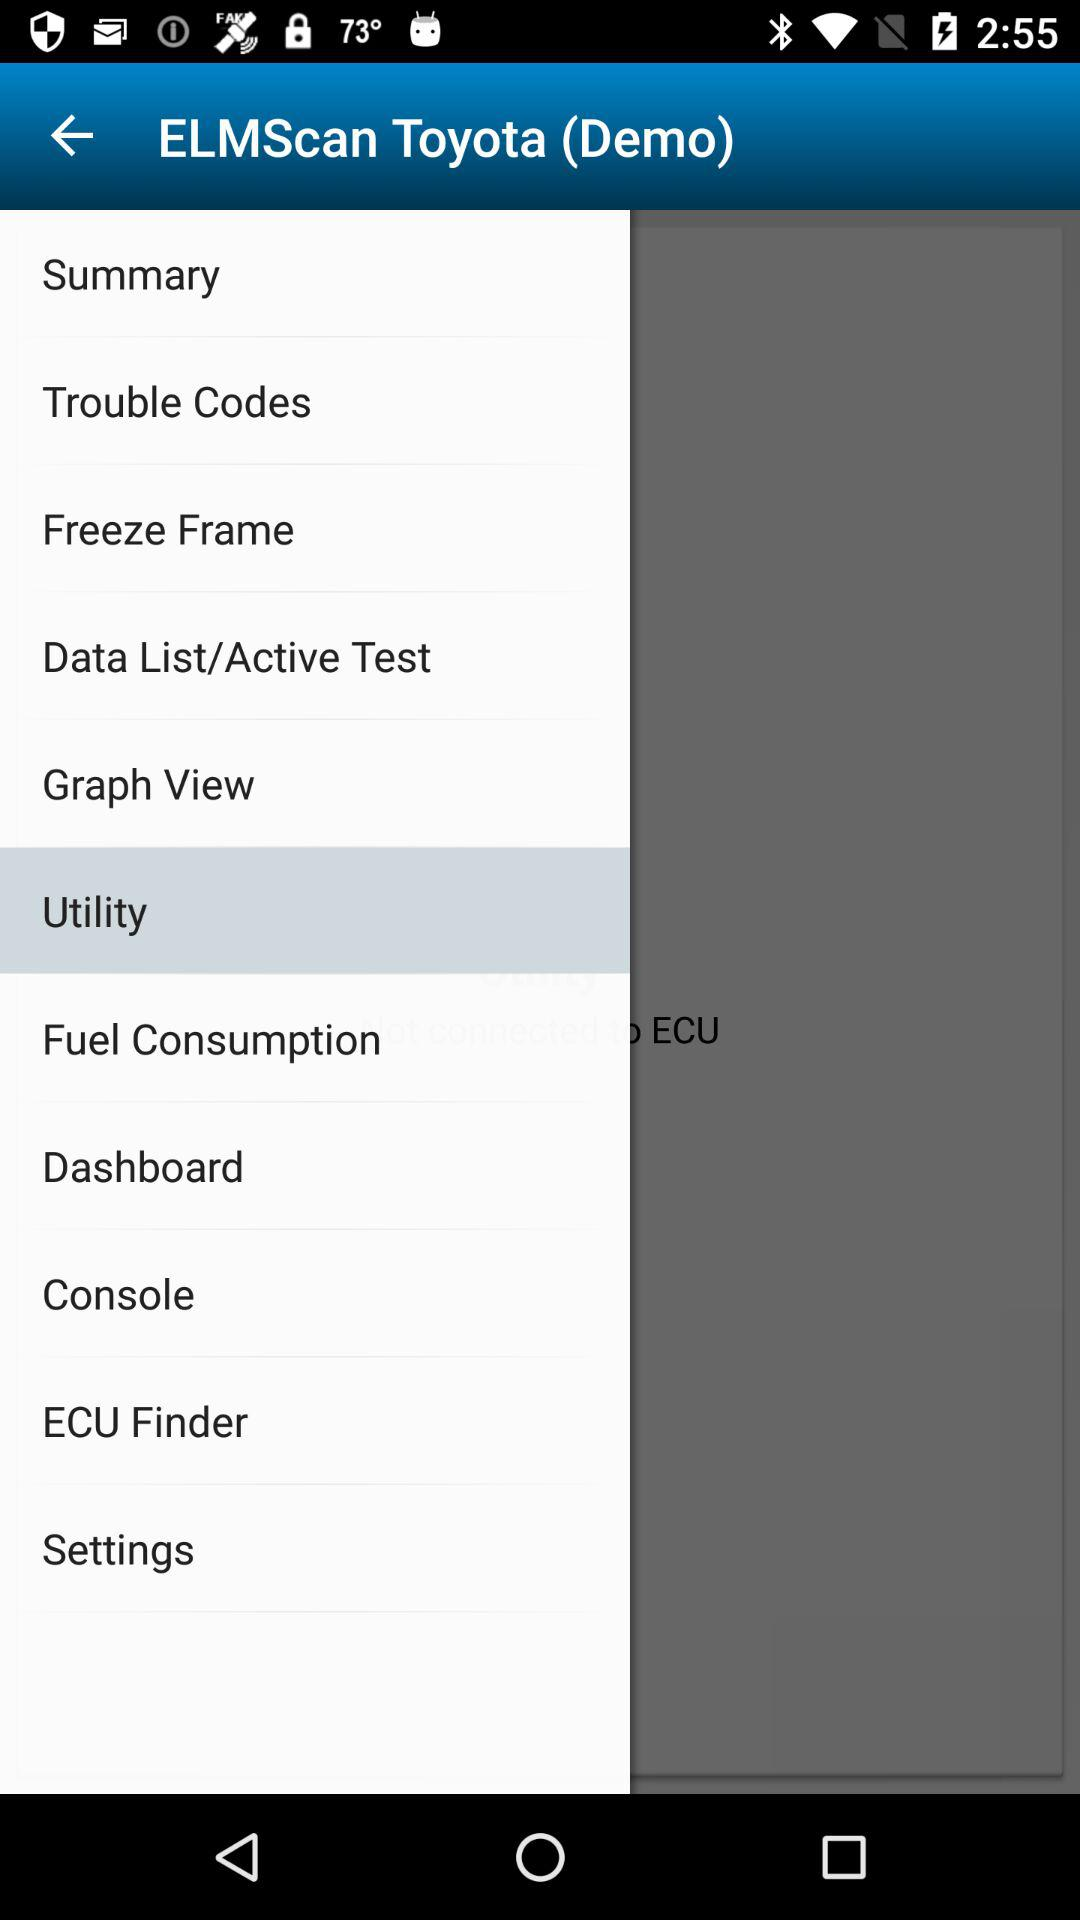What are the trouble codes?
When the provided information is insufficient, respond with <no answer>. <no answer> 